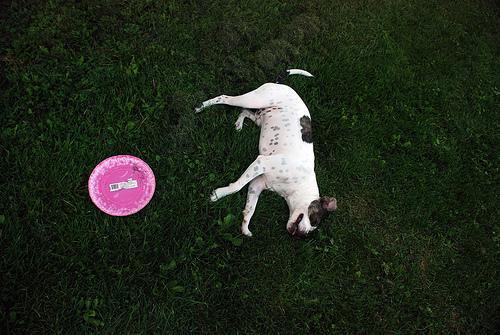How many of the objects in the image are alive?
Give a very brief answer. 1. 